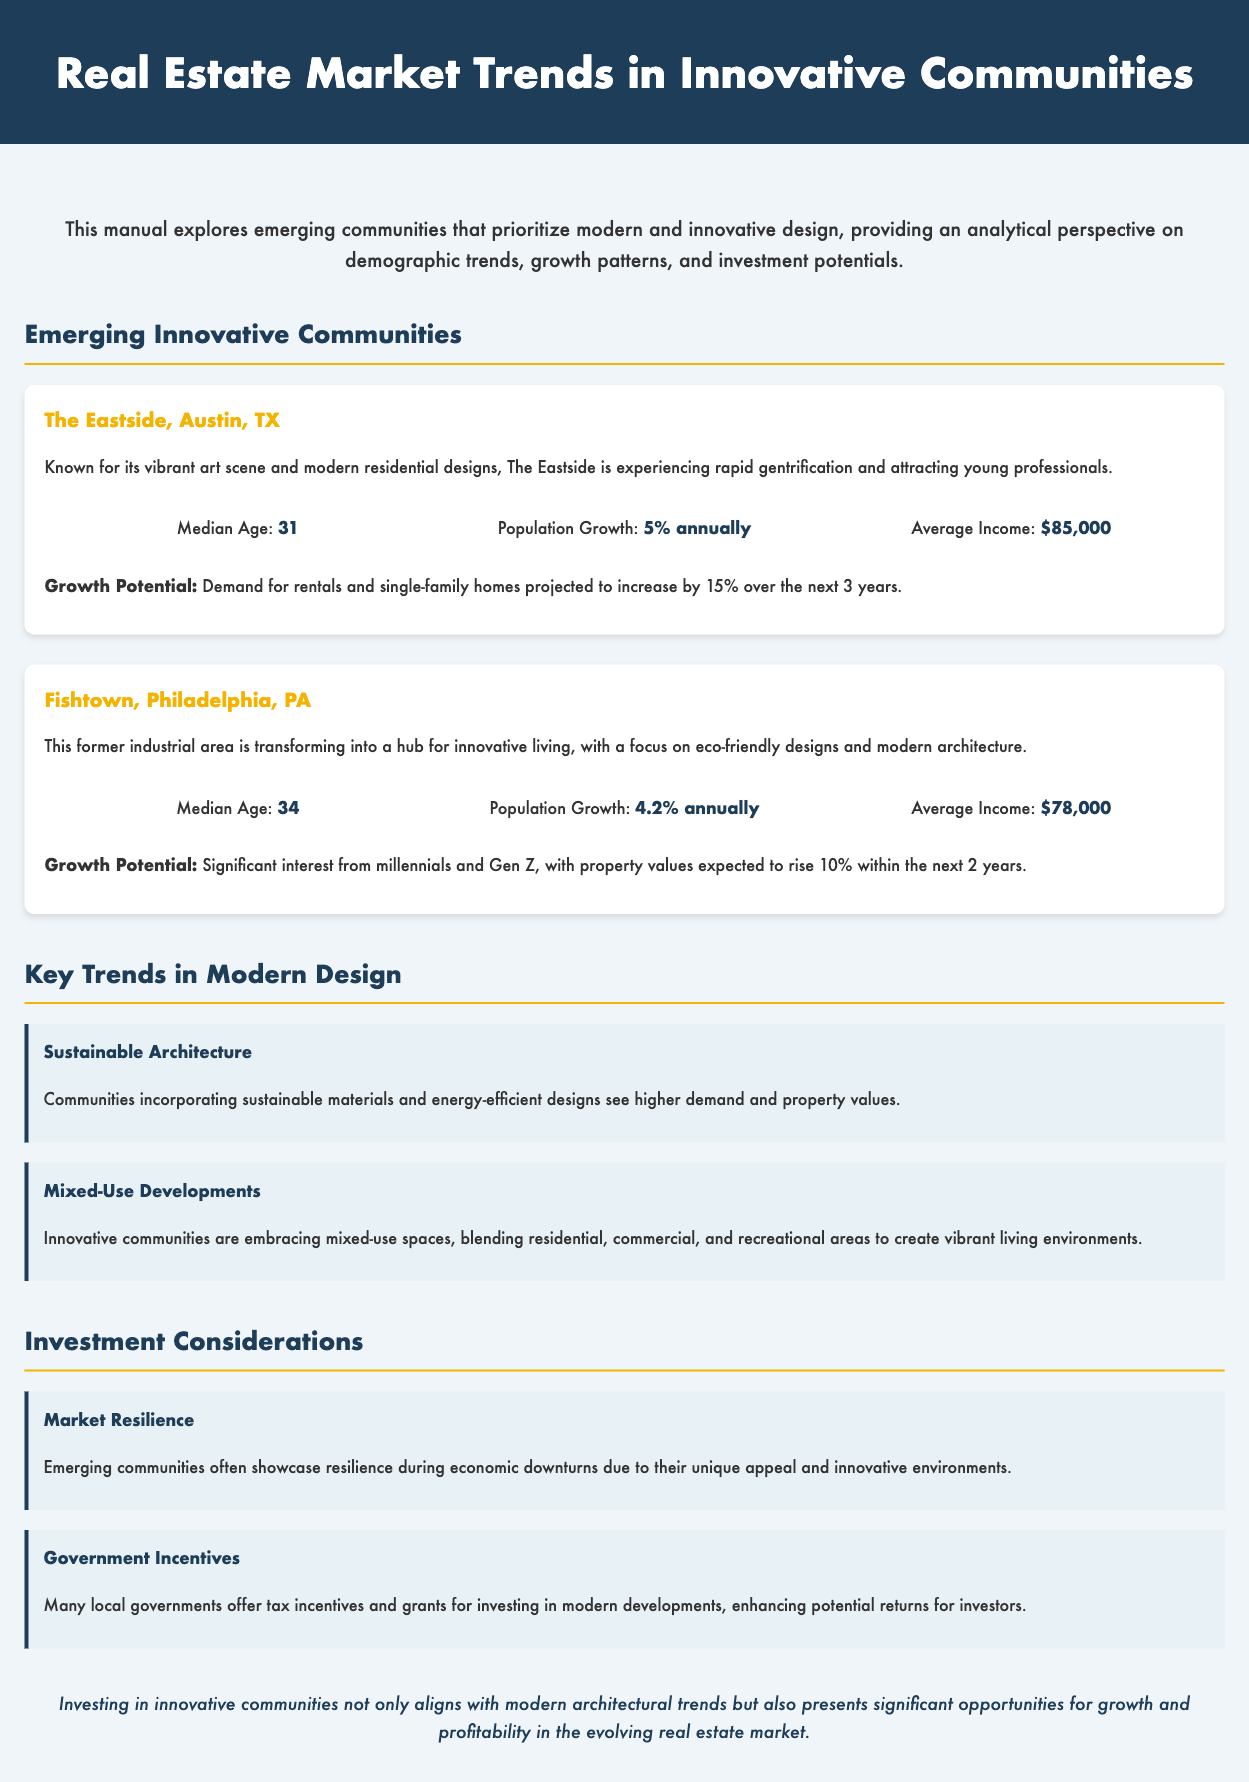What is the median age in The Eastside, Austin, TX? The median age is explicitly stated in the demographics section of The Eastside community, which is 31.
Answer: 31 What is the annual population growth rate for Fishtown, Philadelphia, PA? The population growth rate is mentioned in the Fishtown community demographics, which is 4.2% annually.
Answer: 4.2% annually What is the average income in The Eastside, Austin, TX? The average income is listed in the demographics of The Eastside, which is $85,000.
Answer: $85,000 What trend involves integrating residential and commercial spaces? The document mentions that innovative communities are embracing mixed-use developments that blend residential, commercial, and recreational areas.
Answer: Mixed-Use Developments What government support is mentioned for investing in modern developments? The manual states that local governments offer tax incentives and grants for investing in modern developments.
Answer: Tax incentives and grants What is the projected increase in demand for rentals in The Eastside over the next three years? The document states that the demand for rentals and single-family homes is projected to increase by 15% over the next 3 years.
Answer: 15% What is highlighted as a potential factor for market resilience? The manual indicates that emerging communities often show resilience during economic downturns due to their unique appeal and innovative environments.
Answer: Unique appeal and innovative environments What is the expected increase in property values in Fishtown within the next two years? The document states that property values in Fishtown are expected to rise by 10% within the next 2 years.
Answer: 10% 